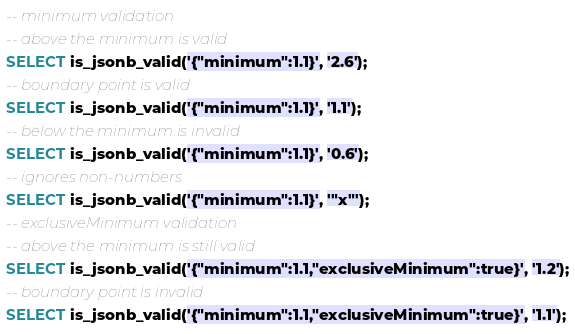<code> <loc_0><loc_0><loc_500><loc_500><_SQL_>-- minimum validation
-- above the minimum is valid
SELECT is_jsonb_valid('{"minimum":1.1}', '2.6');
-- boundary point is valid
SELECT is_jsonb_valid('{"minimum":1.1}', '1.1');
-- below the minimum is invalid
SELECT is_jsonb_valid('{"minimum":1.1}', '0.6');
-- ignores non-numbers
SELECT is_jsonb_valid('{"minimum":1.1}', '"x"');
-- exclusiveMinimum validation
-- above the minimum is still valid
SELECT is_jsonb_valid('{"minimum":1.1,"exclusiveMinimum":true}', '1.2');
-- boundary point is invalid
SELECT is_jsonb_valid('{"minimum":1.1,"exclusiveMinimum":true}', '1.1');</code> 